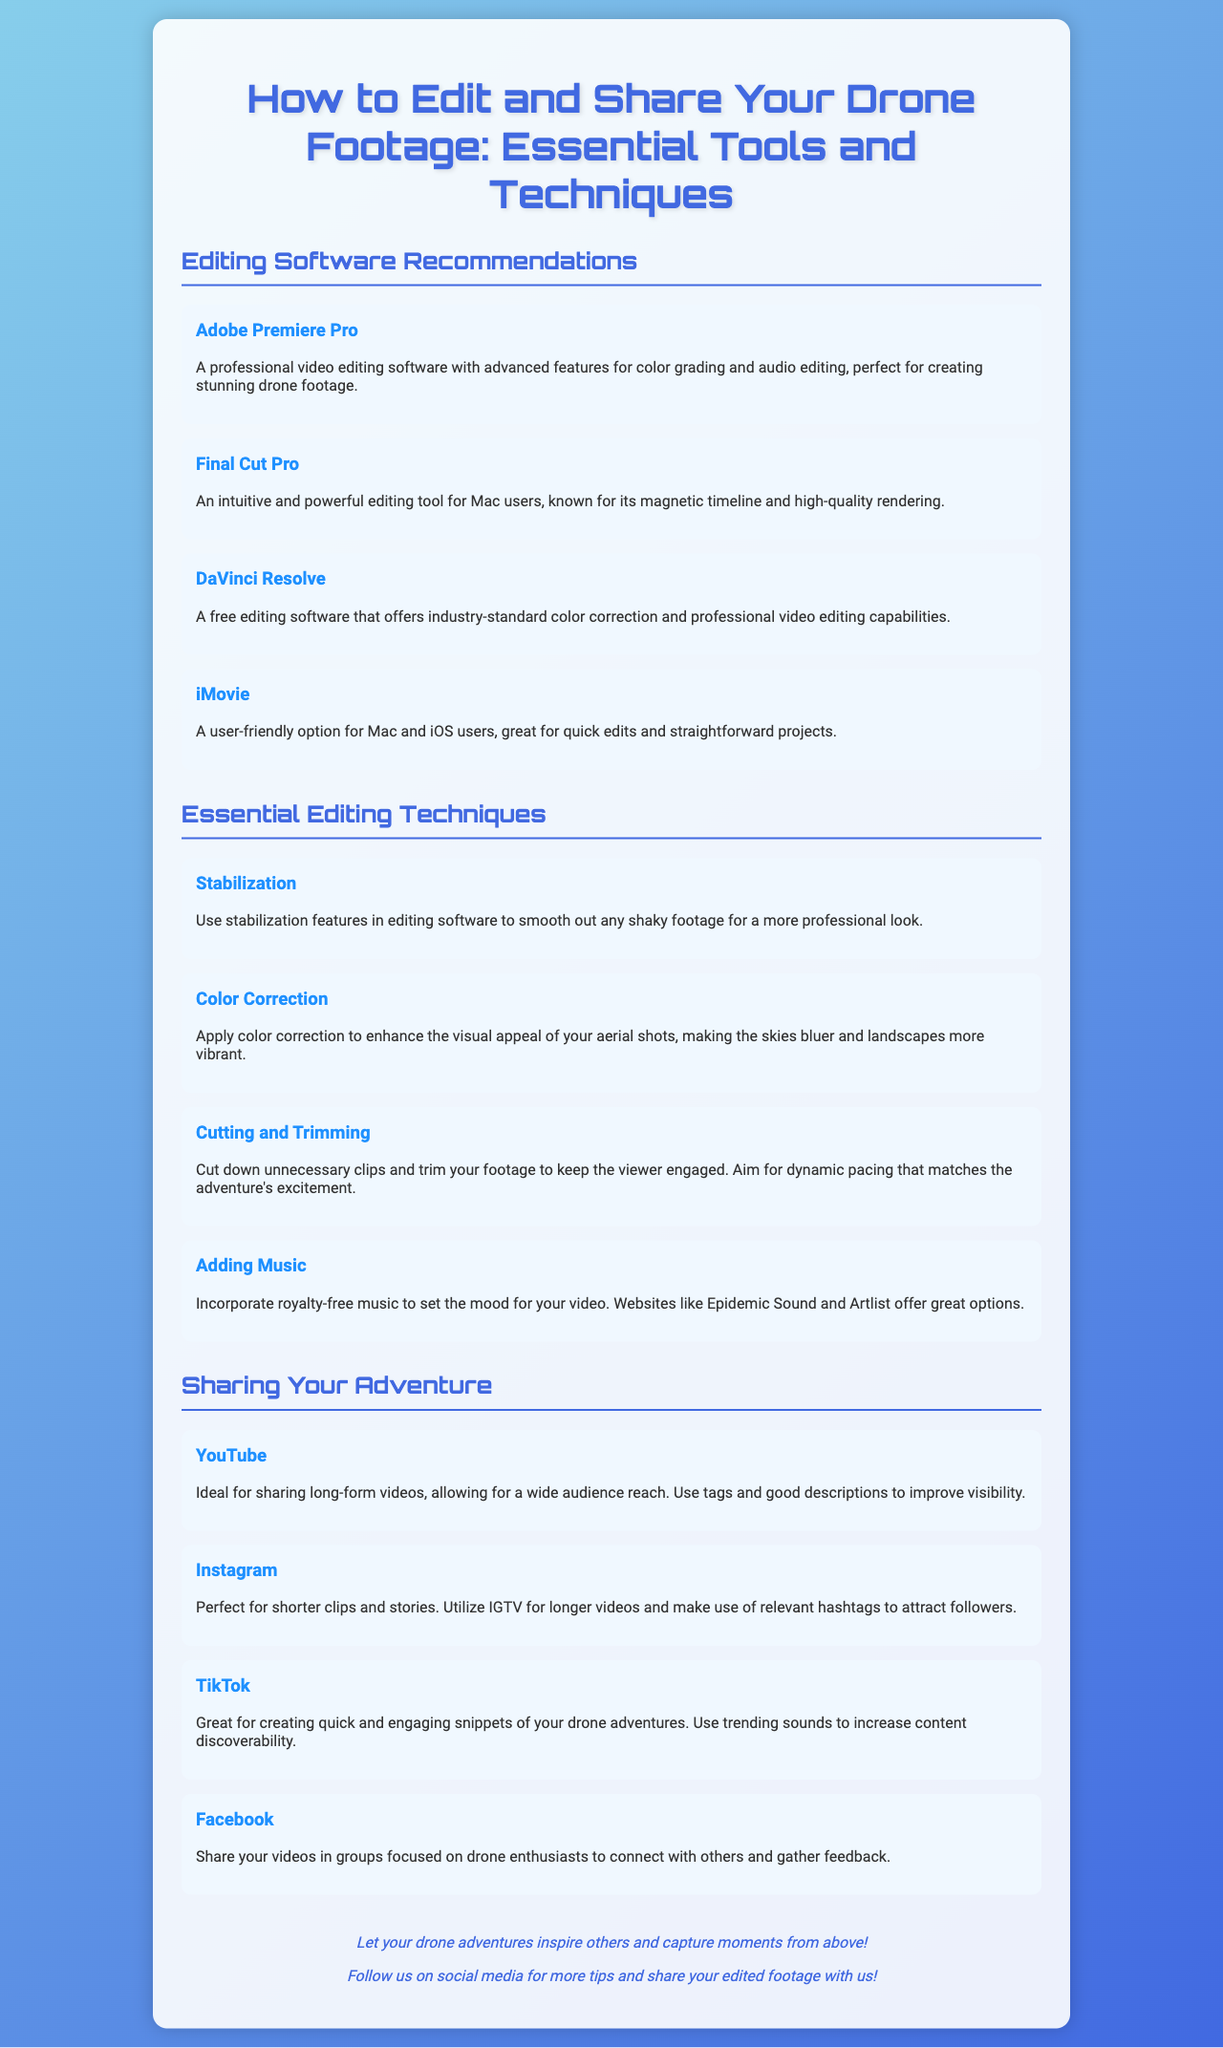What is the title of the brochure? The title of the brochure is mentioned prominently at the beginning of the document.
Answer: How to Edit and Share Your Drone Footage: Essential Tools and Techniques Which software is recommended for color grading? Adobe Premiere Pro is highlighted for its advanced features in color grading.
Answer: Adobe Premiere Pro What is a user-friendly editing option for quick projects? iMovie is specifically mentioned as a user-friendly option for quick edits.
Answer: iMovie What is one essential editing technique listed? The document provides several techniques, and stabilization is one of them.
Answer: Stabilization Which platform is ideal for sharing long-form videos? The brochure states that YouTube is suitable for sharing long-form videos.
Answer: YouTube What type of music should be incorporated into videos? The document suggests using royalty-free music for setting the mood.
Answer: Royalty-free music What is a key suggestion for keeping viewers engaged? The document emphasizes cutting down unnecessary clips to maintain viewer engagement.
Answer: Cut down unnecessary clips What is the acronym used for longer videos on Instagram? IGTV is mentioned in the context of longer videos on Instagram.
Answer: IGTV How can following hashtags benefit video posting on Instagram? The brochure recommends utilizing relevant hashtags to attract followers.
Answer: Attract followers 